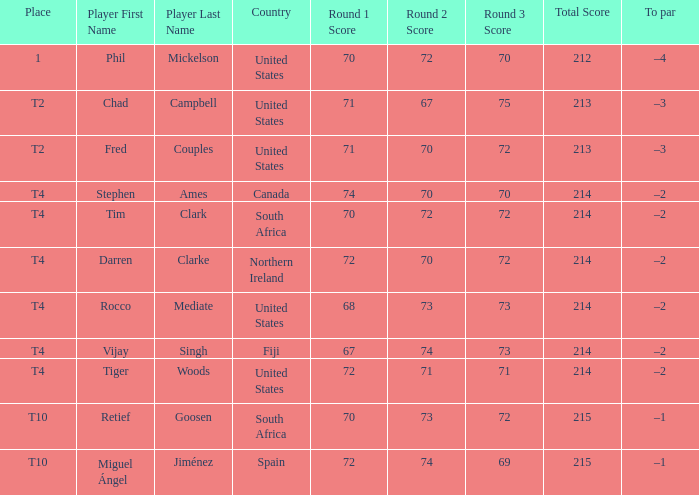What place was the scorer of 67-74-73=214? T4. 